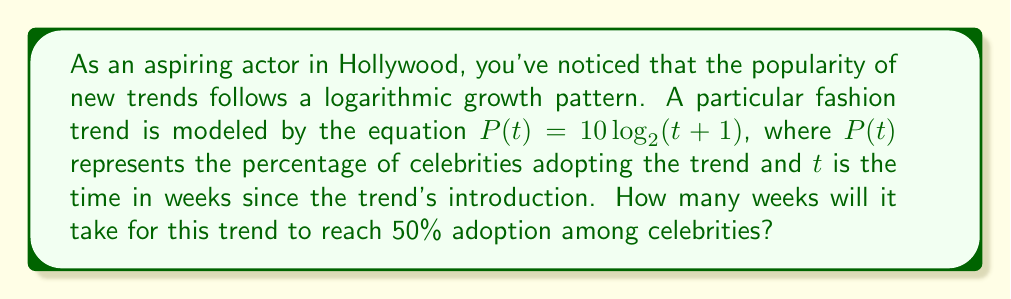Show me your answer to this math problem. To solve this problem, we need to use the given logarithmic equation and solve for $t$ when $P(t) = 50$. Let's break it down step by step:

1) We start with the equation: $P(t) = 10 \log_2(t+1)$

2) We want to find $t$ when $P(t) = 50$, so we substitute this:
   $50 = 10 \log_2(t+1)$

3) Divide both sides by 10:
   $5 = \log_2(t+1)$

4) To solve for $t$, we need to apply the inverse function (exponential) to both sides:
   $2^5 = t+1$

5) Calculate $2^5$:
   $32 = t+1$

6) Subtract 1 from both sides:
   $31 = t$

Therefore, it will take 31 weeks for the trend to reach 50% adoption among celebrities.
Answer: 31 weeks 